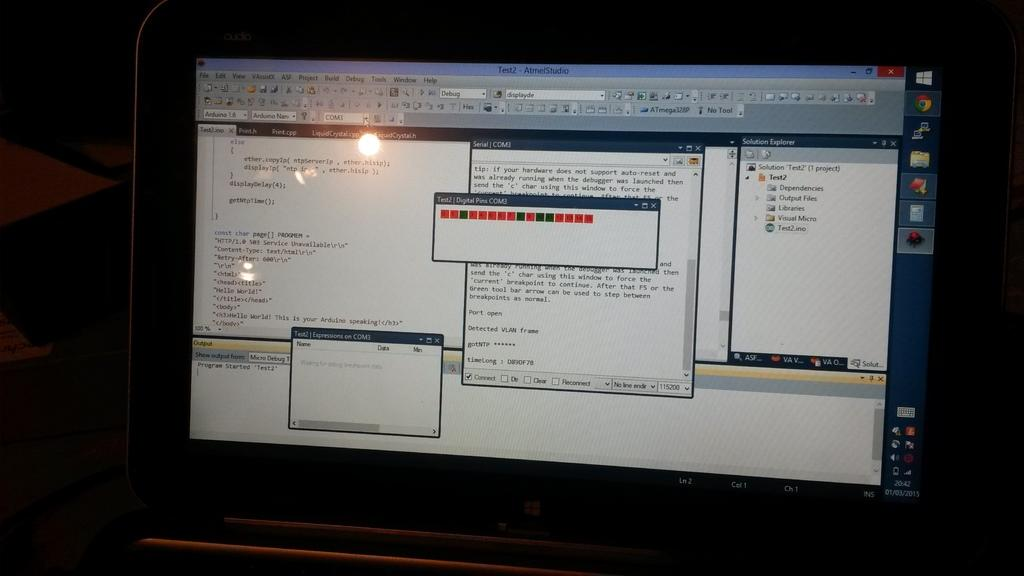<image>
Relay a brief, clear account of the picture shown. computer screen showing that atmelstudio is running test2 on com3 